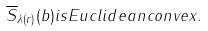Convert formula to latex. <formula><loc_0><loc_0><loc_500><loc_500>\overline { S } _ { \lambda ( r ) } ( b ) i s E u c l i d e a n c o n v e x .</formula> 